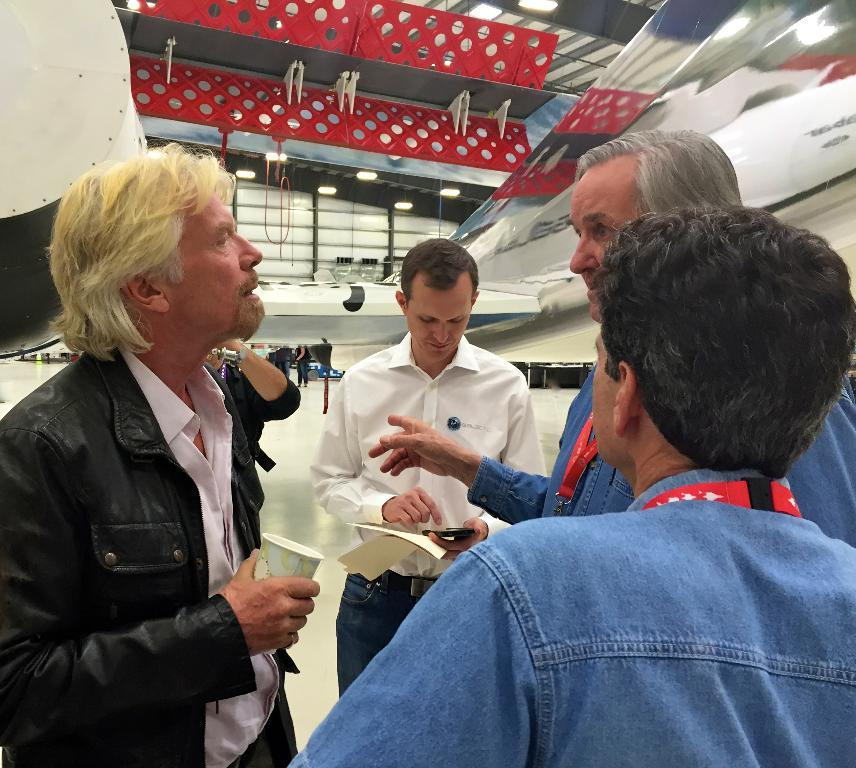How many people are in the image? There are five persons standing in the image. Where are the persons standing? The persons are standing on the floor. What can be seen in the background of the image? There is a wall, a staircase, a rooftop, and some objects visible in the background of the image. What type of location might the image have been taken in? The image may have been taken in a hall. What type of popcorn is being served during the voyage in the image? There is no reference to a voyage or popcorn in the image; it features five persons standing on the floor with a background that includes a wall, a staircase, a rooftop, and some objects. 